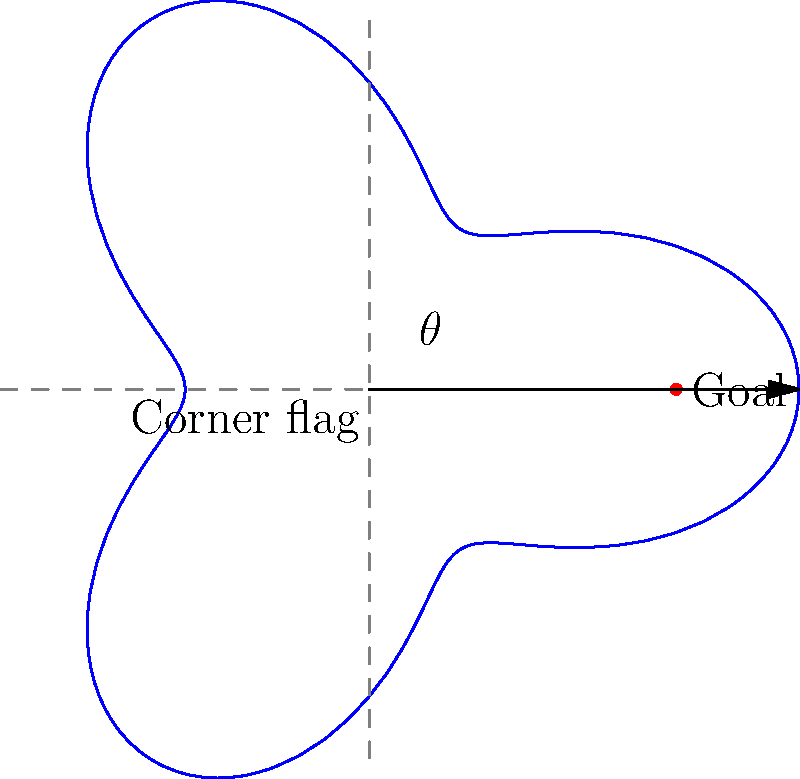In a football match, you're tasked with taking a corner kick. The diagram shows the path of the ball using polar coordinates, where $r(\theta) = 50 + 20\cos(3\theta)$. The goal is located at $(50,0)$ in polar coordinates. At what angle $\theta$ (in radians) should you kick the ball to have the best chance of scoring directly from the corner? To find the optimal angle for the corner kick, we need to determine when the ball is closest to the goal. This occurs when $r(\theta)$ is at its minimum value.

1) The function for $r(\theta)$ is given as $r(\theta) = 50 + 20\cos(3\theta)$

2) To find the minimum value, we need to find where the derivative $\frac{dr}{d\theta} = 0$:

   $\frac{dr}{d\theta} = -60\sin(3\theta)$

3) Setting this equal to zero:
   
   $-60\sin(3\theta) = 0$
   $\sin(3\theta) = 0$

4) The solutions to this equation are:
   
   $3\theta = 0, \pi, 2\pi, ...$

5) In the range $[0, 2\pi]$, this gives us:
   
   $\theta = 0, \frac{\pi}{3}, \frac{2\pi}{3}$

6) To determine which of these gives the minimum $r$, we can substitute these values back into the original function:

   At $\theta = 0$: $r(0) = 50 + 20 = 70$
   At $\theta = \frac{\pi}{3}$: $r(\frac{\pi}{3}) = 50 + 20\cos(\pi) = 30$
   At $\theta = \frac{2\pi}{3}$: $r(\frac{2\pi}{3}) = 50 + 20\cos(2\pi) = 70$

7) The minimum value occurs at $\theta = \frac{\pi}{3}$, which is the optimal angle for the corner kick.
Answer: $\frac{\pi}{3}$ radians 